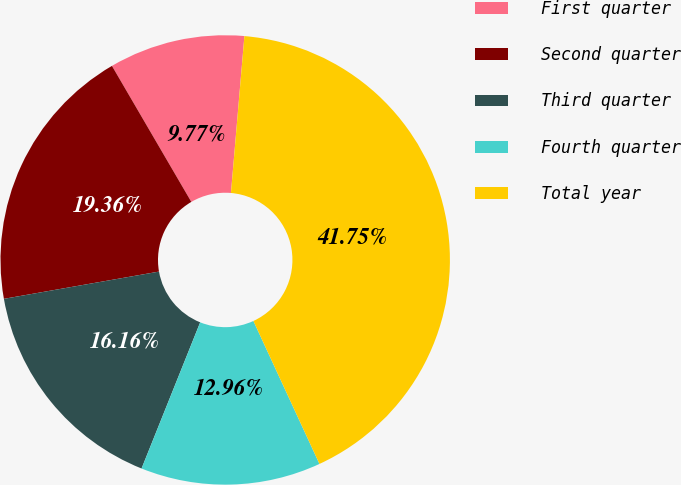Convert chart to OTSL. <chart><loc_0><loc_0><loc_500><loc_500><pie_chart><fcel>First quarter<fcel>Second quarter<fcel>Third quarter<fcel>Fourth quarter<fcel>Total year<nl><fcel>9.77%<fcel>19.36%<fcel>16.16%<fcel>12.96%<fcel>41.75%<nl></chart> 